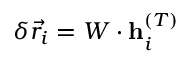Convert formula to latex. <formula><loc_0><loc_0><loc_500><loc_500>\delta \vec { r } _ { i } = W \cdot h _ { i } ^ { ( T ) }</formula> 